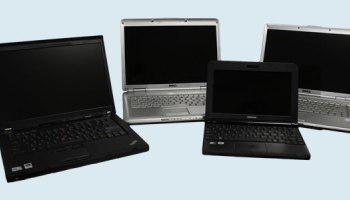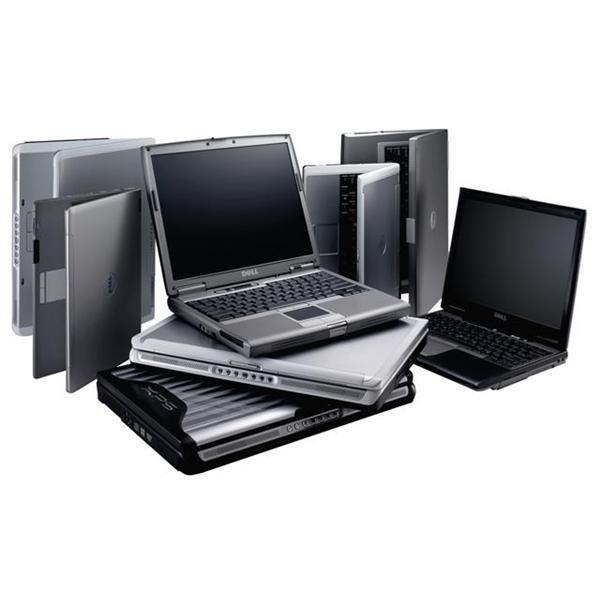The first image is the image on the left, the second image is the image on the right. Examine the images to the left and right. Is the description "There are more laptop-type devices in the right image than in the left." accurate? Answer yes or no. Yes. The first image is the image on the left, the second image is the image on the right. Analyze the images presented: Is the assertion "All the screens in the image on the right are turned off." valid? Answer yes or no. Yes. 